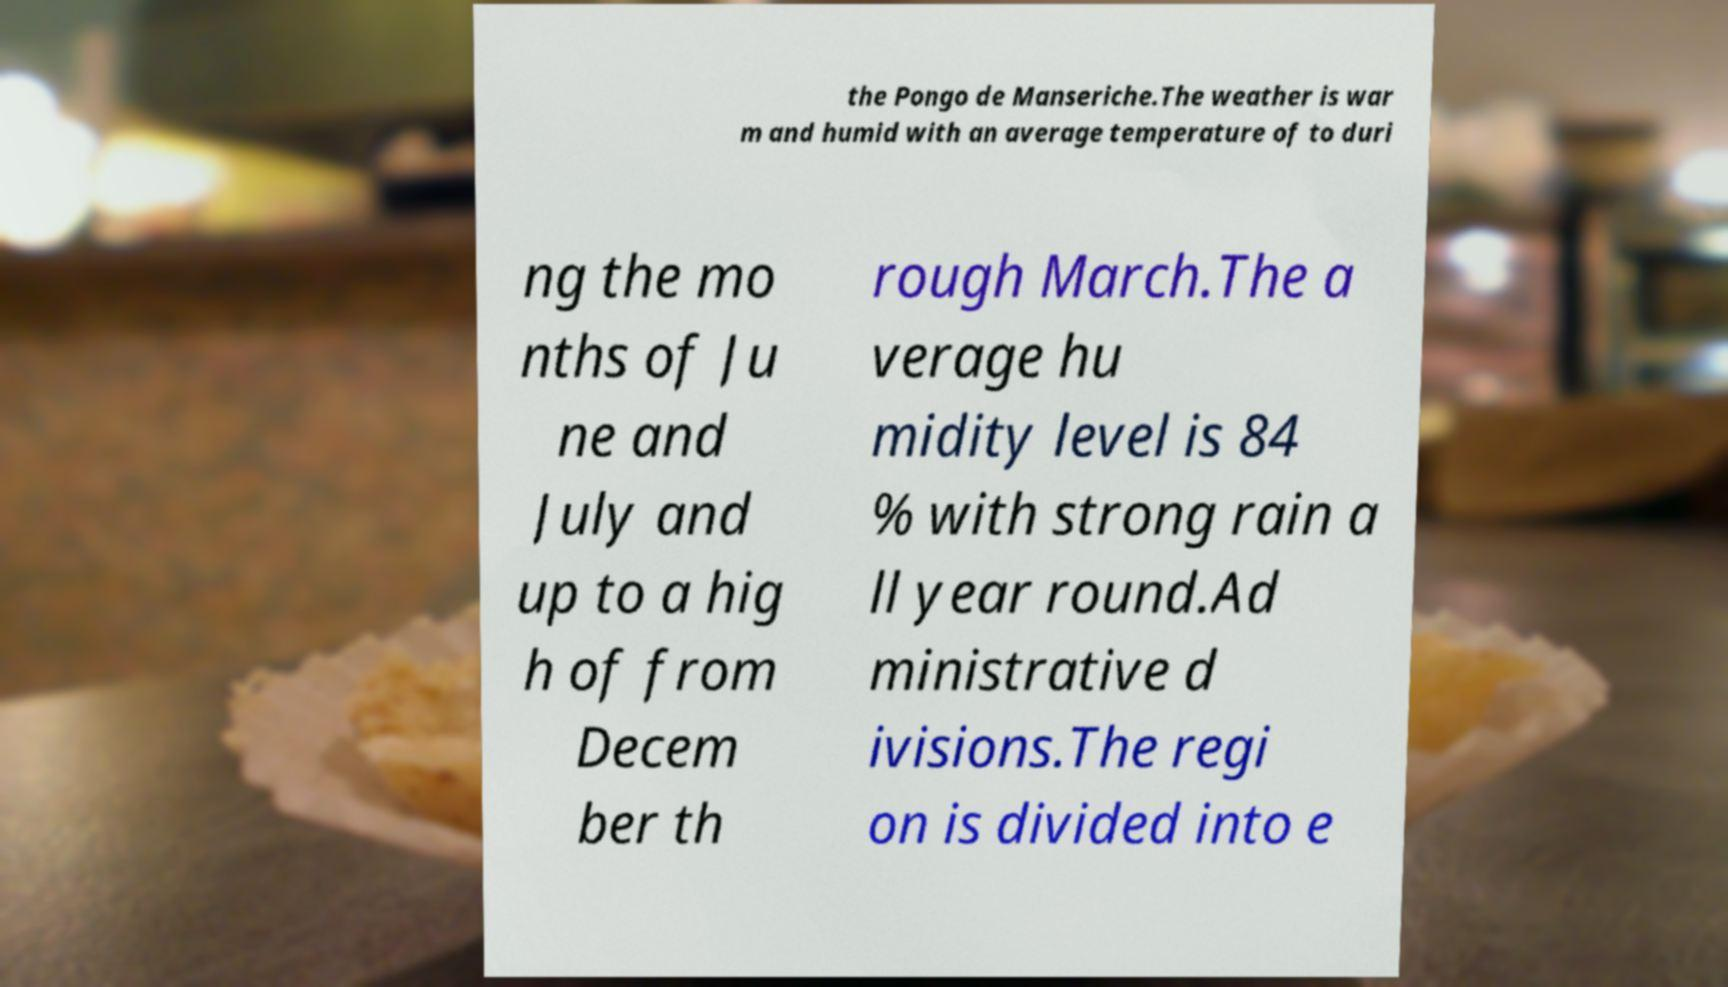Please identify and transcribe the text found in this image. the Pongo de Manseriche.The weather is war m and humid with an average temperature of to duri ng the mo nths of Ju ne and July and up to a hig h of from Decem ber th rough March.The a verage hu midity level is 84 % with strong rain a ll year round.Ad ministrative d ivisions.The regi on is divided into e 